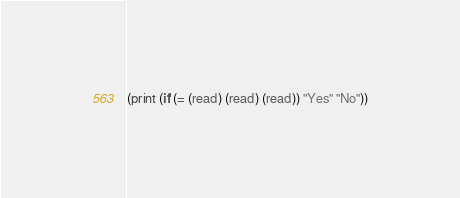<code> <loc_0><loc_0><loc_500><loc_500><_Scheme_>(print (if (= (read) (read) (read)) "Yes" "No"))</code> 